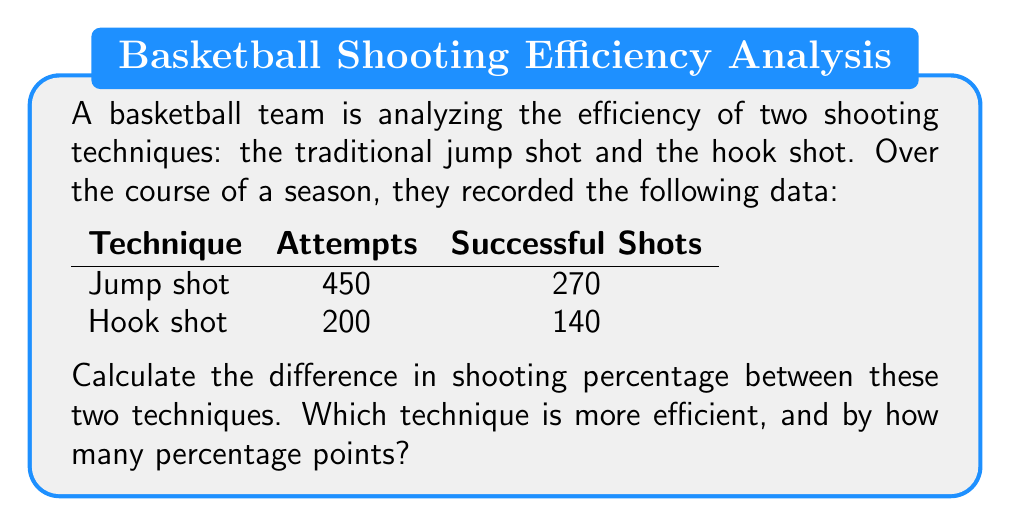Can you solve this math problem? To solve this problem, we need to follow these steps:

1. Calculate the shooting percentage for each technique:

   Jump shot percentage:
   $$\text{Jump shot } \% = \frac{\text{Successful shots}}{\text{Total attempts}} \times 100\%$$
   $$\text{Jump shot } \% = \frac{270}{450} \times 100\% = 60\%$$

   Hook shot percentage:
   $$\text{Hook shot } \% = \frac{\text{Successful shots}}{\text{Total attempts}} \times 100\%$$
   $$\text{Hook shot } \% = \frac{140}{200} \times 100\% = 70\%$$

2. Calculate the difference in shooting percentage:
   $$\text{Difference} = \text{Hook shot } \% - \text{Jump shot } \%$$
   $$\text{Difference} = 70\% - 60\% = 10\%$$

3. Determine which technique is more efficient:
   The hook shot has a higher shooting percentage (70%) compared to the jump shot (60%), so it is more efficient.

4. Express the difference in percentage points:
   The difference of 10% is equivalent to 10 percentage points.
Answer: The hook shot is more efficient by 10 percentage points. 